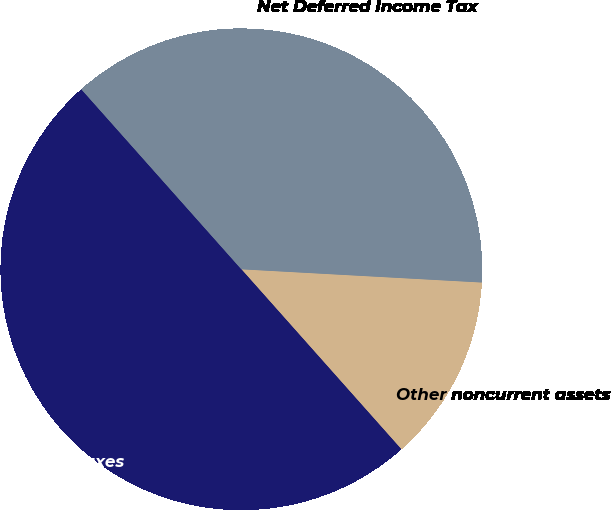Convert chart. <chart><loc_0><loc_0><loc_500><loc_500><pie_chart><fcel>Other noncurrent assets<fcel>Deferred income taxes<fcel>Net Deferred Income Tax<nl><fcel>12.56%<fcel>50.0%<fcel>37.44%<nl></chart> 